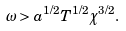<formula> <loc_0><loc_0><loc_500><loc_500>\omega > a ^ { 1 / 2 } T ^ { 1 / 2 } \chi ^ { 3 / 2 } .</formula> 